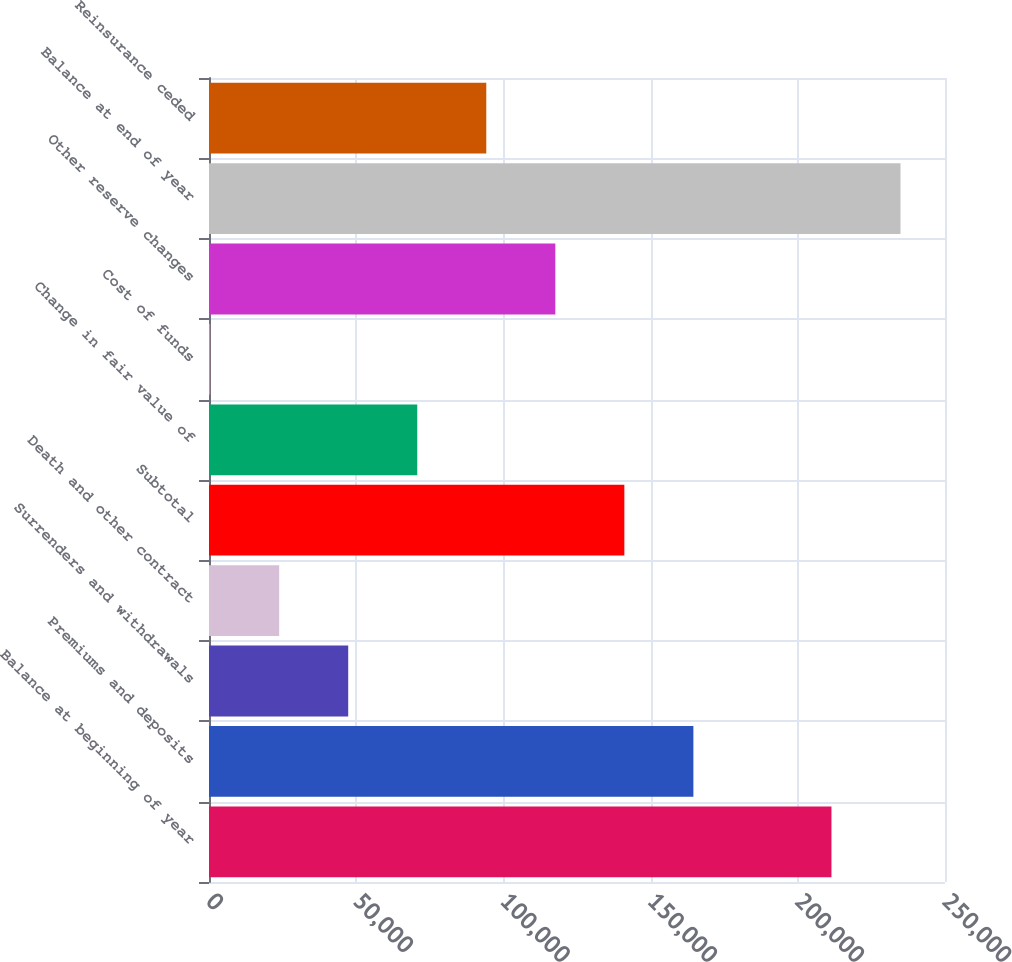<chart> <loc_0><loc_0><loc_500><loc_500><bar_chart><fcel>Balance at beginning of year<fcel>Premiums and deposits<fcel>Surrenders and withdrawals<fcel>Death and other contract<fcel>Subtotal<fcel>Change in fair value of<fcel>Cost of funds<fcel>Other reserve changes<fcel>Balance at end of year<fcel>Reinsurance ceded<nl><fcel>211434<fcel>164535<fcel>47285.6<fcel>23835.8<fcel>141085<fcel>70735.4<fcel>386<fcel>117635<fcel>234884<fcel>94185.2<nl></chart> 